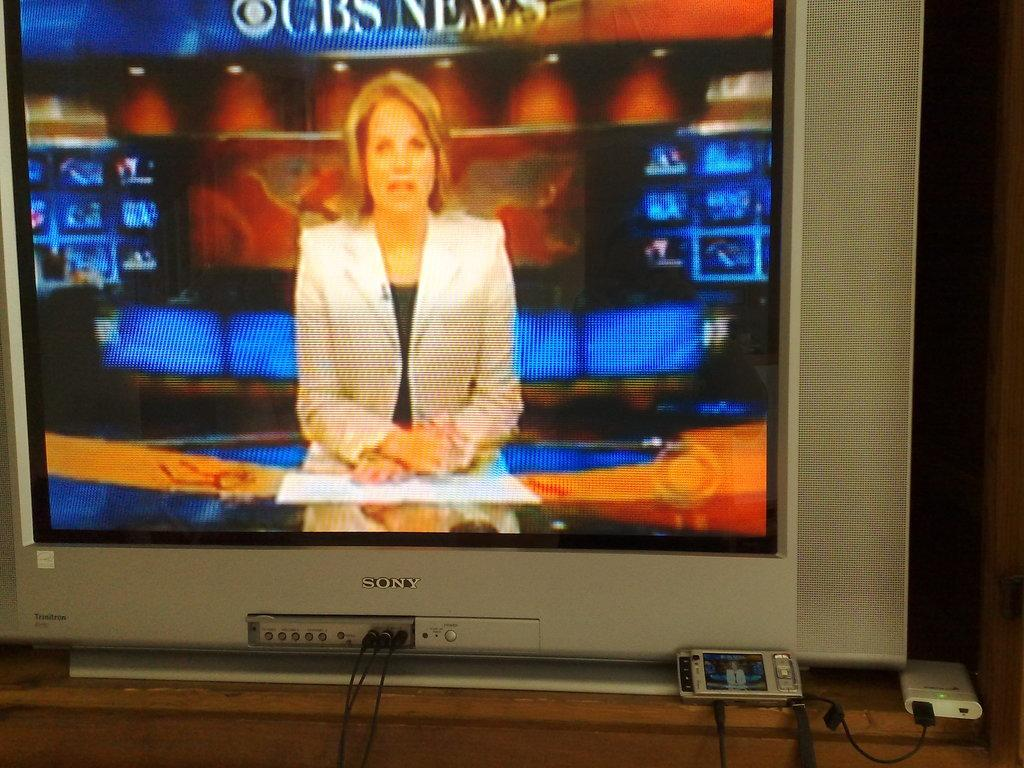<image>
Render a clear and concise summary of the photo. A sony branded television is displaying cbs news on its screen. 